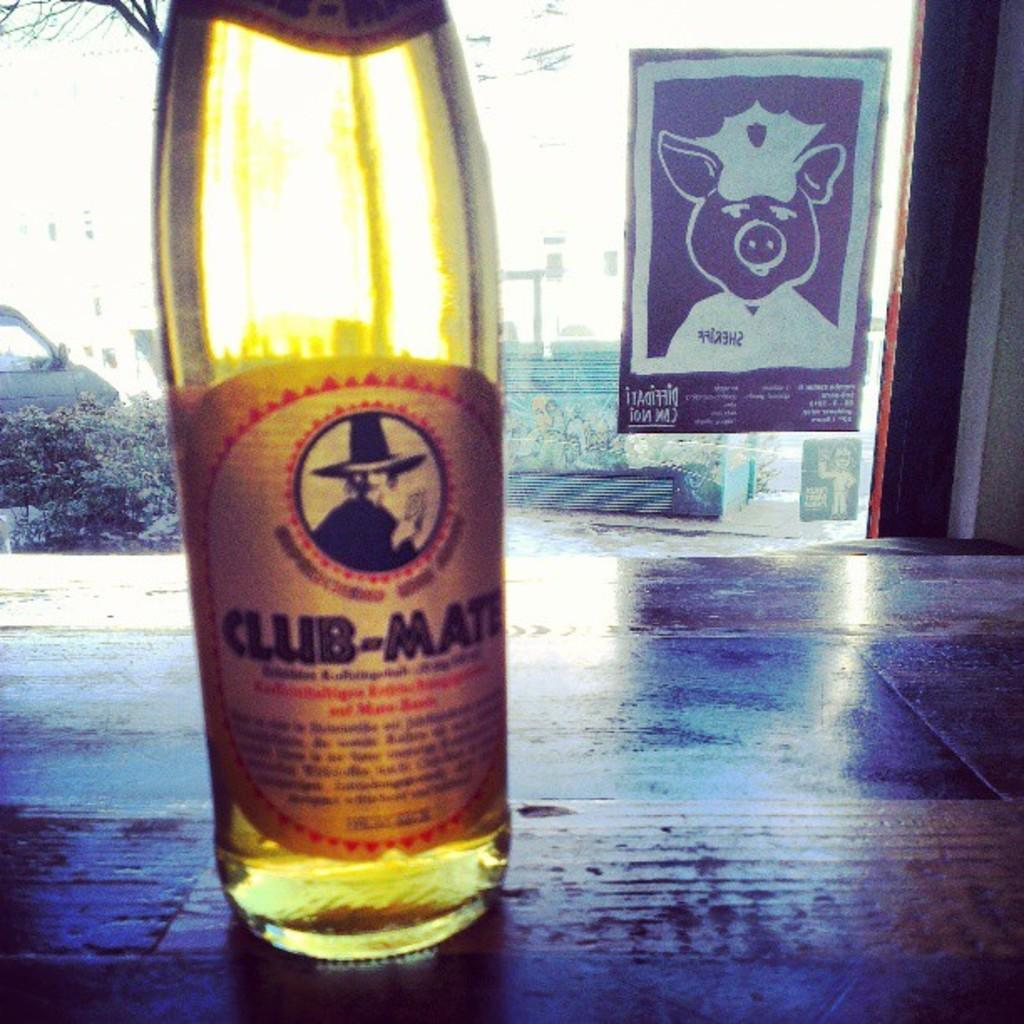What object is placed on the table in the image? There is a bottle on the table in the image. What can be seen behind the bottle? There is a car behind the bottle in the image. What type of living organisms are visible in the image? Plants are present in the image. How would you describe the weather or lighting in the image? The background appears to be sunny in the image. What type of gold jewelry is the kitty wearing during the operation in the image? There is no kitty or operation present in the image, and therefore no such activity or jewelry can be observed. 